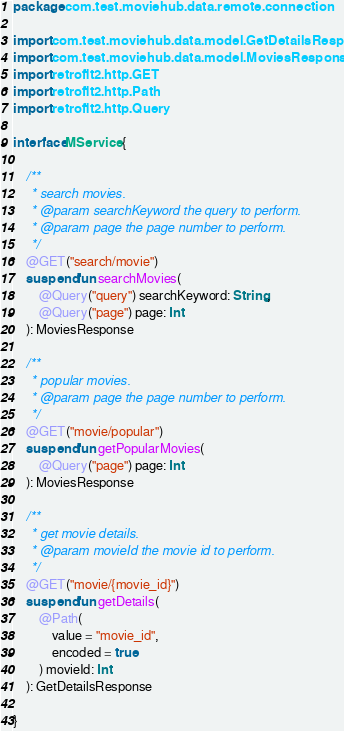<code> <loc_0><loc_0><loc_500><loc_500><_Kotlin_>package com.test.moviehub.data.remote.connection

import com.test.moviehub.data.model.GetDetailsResponse
import com.test.moviehub.data.model.MoviesResponse
import retrofit2.http.GET
import retrofit2.http.Path
import retrofit2.http.Query

interface MService {

    /**
     * search movies.
     * @param searchKeyword the query to perform.
     * @param page the page number to perform.
     */
    @GET("search/movie")
    suspend fun searchMovies(
        @Query("query") searchKeyword: String,
        @Query("page") page: Int
    ): MoviesResponse

    /**
     * popular movies.
     * @param page the page number to perform.
     */
    @GET("movie/popular")
    suspend fun getPopularMovies(
        @Query("page") page: Int
    ): MoviesResponse

    /**
     * get movie details.
     * @param movieId the movie id to perform.
     */
    @GET("movie/{movie_id}")
    suspend fun getDetails(
        @Path(
            value = "movie_id",
            encoded = true
        ) movieId: Int
    ): GetDetailsResponse

}</code> 